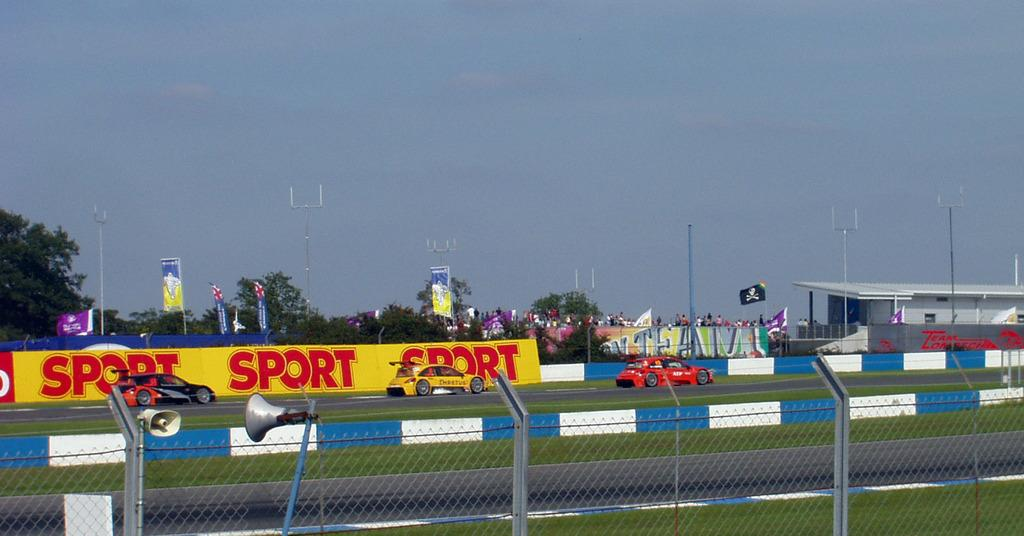<image>
Render a clear and concise summary of the photo. A sunny day at a sock car race and cars whiz boy in front of Sport Sport Sport sign 